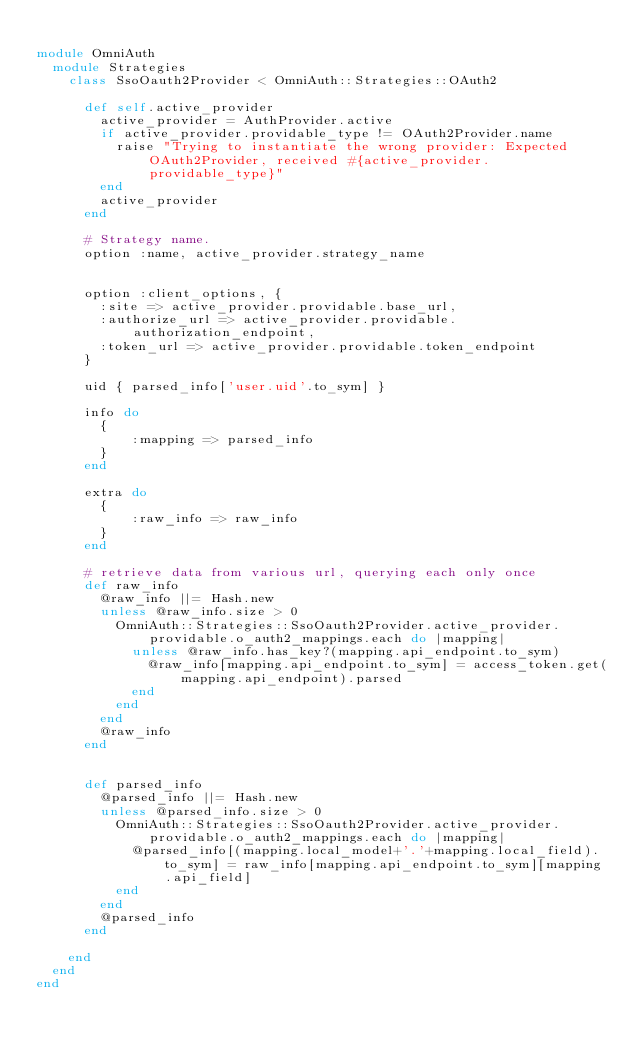Convert code to text. <code><loc_0><loc_0><loc_500><loc_500><_Ruby_>
module OmniAuth
  module Strategies
    class SsoOauth2Provider < OmniAuth::Strategies::OAuth2

      def self.active_provider
        active_provider = AuthProvider.active
        if active_provider.providable_type != OAuth2Provider.name
          raise "Trying to instantiate the wrong provider: Expected OAuth2Provider, received #{active_provider.providable_type}"
        end
        active_provider
      end

      # Strategy name.
      option :name, active_provider.strategy_name


      option :client_options, {
        :site => active_provider.providable.base_url,
        :authorize_url => active_provider.providable.authorization_endpoint,
        :token_url => active_provider.providable.token_endpoint
      }

      uid { parsed_info['user.uid'.to_sym] }

      info do
        {
            :mapping => parsed_info
        }
      end

      extra do
        {
            :raw_info => raw_info
        }
      end

      # retrieve data from various url, querying each only once
      def raw_info
        @raw_info ||= Hash.new
        unless @raw_info.size > 0
          OmniAuth::Strategies::SsoOauth2Provider.active_provider.providable.o_auth2_mappings.each do |mapping|
            unless @raw_info.has_key?(mapping.api_endpoint.to_sym)
              @raw_info[mapping.api_endpoint.to_sym] = access_token.get(mapping.api_endpoint).parsed
            end
          end
        end
        @raw_info
      end


      def parsed_info
        @parsed_info ||= Hash.new
        unless @parsed_info.size > 0
          OmniAuth::Strategies::SsoOauth2Provider.active_provider.providable.o_auth2_mappings.each do |mapping|
            @parsed_info[(mapping.local_model+'.'+mapping.local_field).to_sym] = raw_info[mapping.api_endpoint.to_sym][mapping.api_field]
          end
        end
        @parsed_info
      end

    end
  end
end</code> 